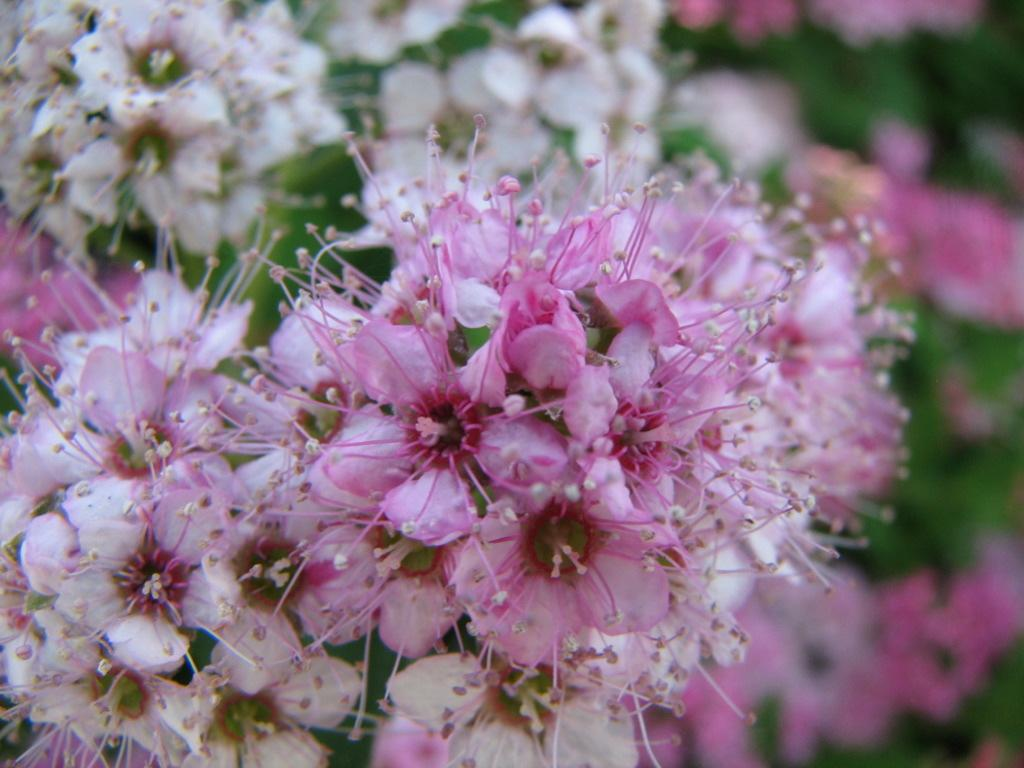What is the main subject of the image? The main subject of the image is a bunch of flowers. Can you describe the colors of the flowers? The flowers are pink and white in color. What type of volleyball game is being played in the image? There is no volleyball game present in the image; it features a bunch of flowers. What type of industry is depicted in the image? There is no industry depicted in the image; it features a bunch of flowers. 